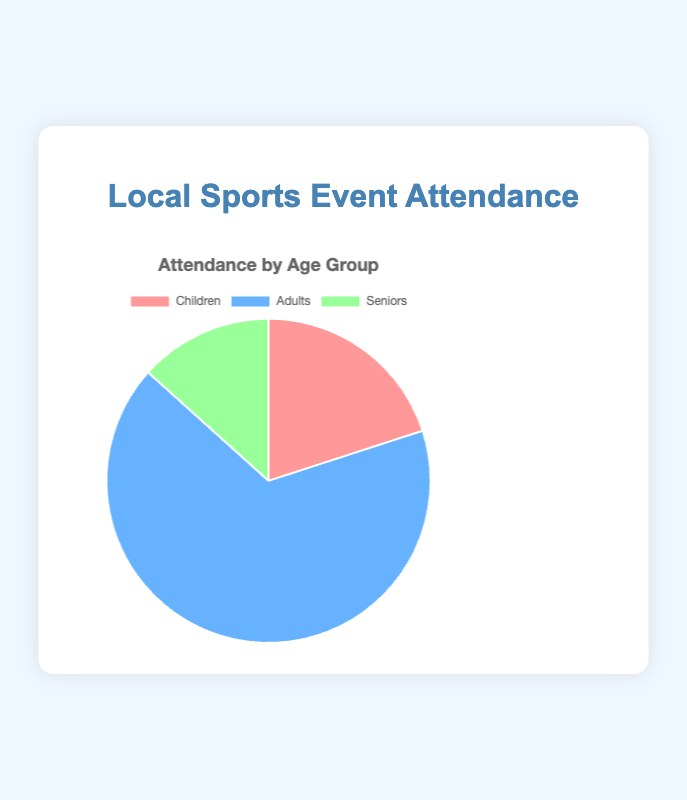What age group has the highest attendance? The pie chart's section for "Adults" is the largest portion of the chart, indicating the highest attendance.
Answer: Adults What is the total attendance across all age groups? Adding up all the given data points: Children: 150, Adults: 500, Seniors: 100. So, 150 + 500 + 100 equals 750.
Answer: 750 How much more is the attendance of Adults compared to Seniors? Subtract the attendance of Seniors from the attendance of Adults: 500 - 100 equals 400.
Answer: 400 Which age group has the smallest attendance? The pie chart’s section for "Seniors" is the smallest portion, indicating the smallest attendance.
Answer: Seniors What percentage of the total attendance do Children represent? First, find the total attendance: 150 (Children) + 500 (Adults) + 100 (Seniors) = 750. Then, calculate the percentage for Children: (150 / 750) * 100 = 20%.
Answer: 20% If you were to combine the attendance of Children and Seniors, how would it compare to the attendance of Adults? Combine the attendance of Children and Seniors: 150 + 100 = 250. Compare it to the attendance of Adults: 250 (Children + Seniors) is less than 500 (Adults).
Answer: Less than Adults What fraction of the total attendance is composed of Seniors? The total attendance is 750. The attendance for Seniors is 100. Therefore, the fraction is 100 / 750, which simplifies to 2 / 15.
Answer: 2/15 What is the attendance difference between Children and Seniors? Subtract the attendance of Seniors from the attendance of Children: 150 - 100 equals 50.
Answer: 50 What color represents the Adults' attendance in the pie chart? The pie chart section for Adults is represented by the color blue.
Answer: Blue 